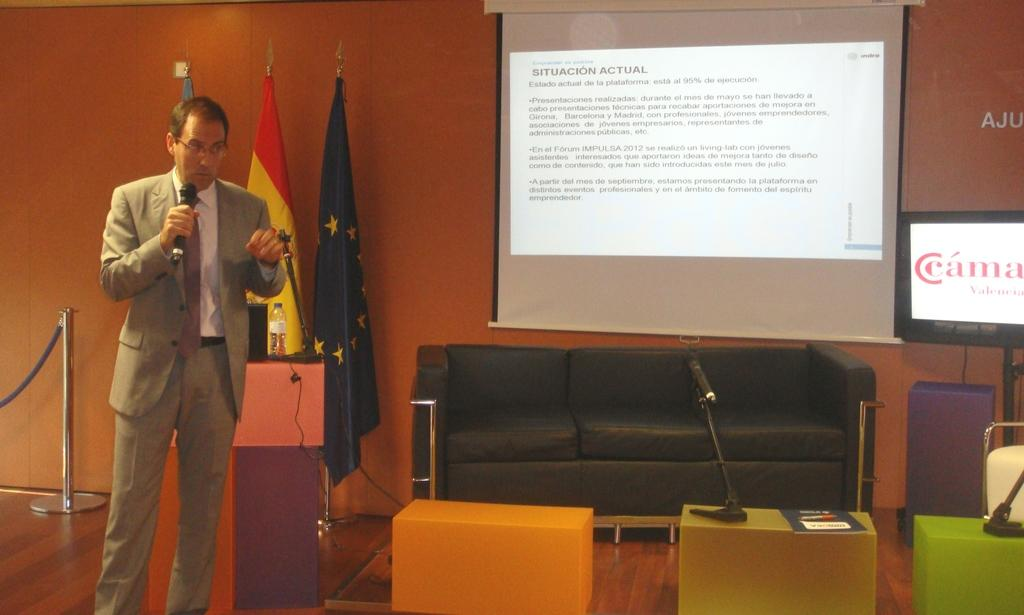What is the main subject of the image? There is a man in the image. What is the man doing in the image? The man is standing in the image. What object is the man holding in his hand? The man is holding a microphone in his hand. What can be seen in the background of the image? There is a metal rod, flags, a water bottle, a sofa, and a projector screen in the background of the image. How many rabbits are sitting on the sofa in the image? There are no rabbits present in the image; the sofa is empty. What type of umbrella is being used to shield the projector screen from the sun? There is no umbrella present in the image, and the projector screen is not being shielded from the sun. 